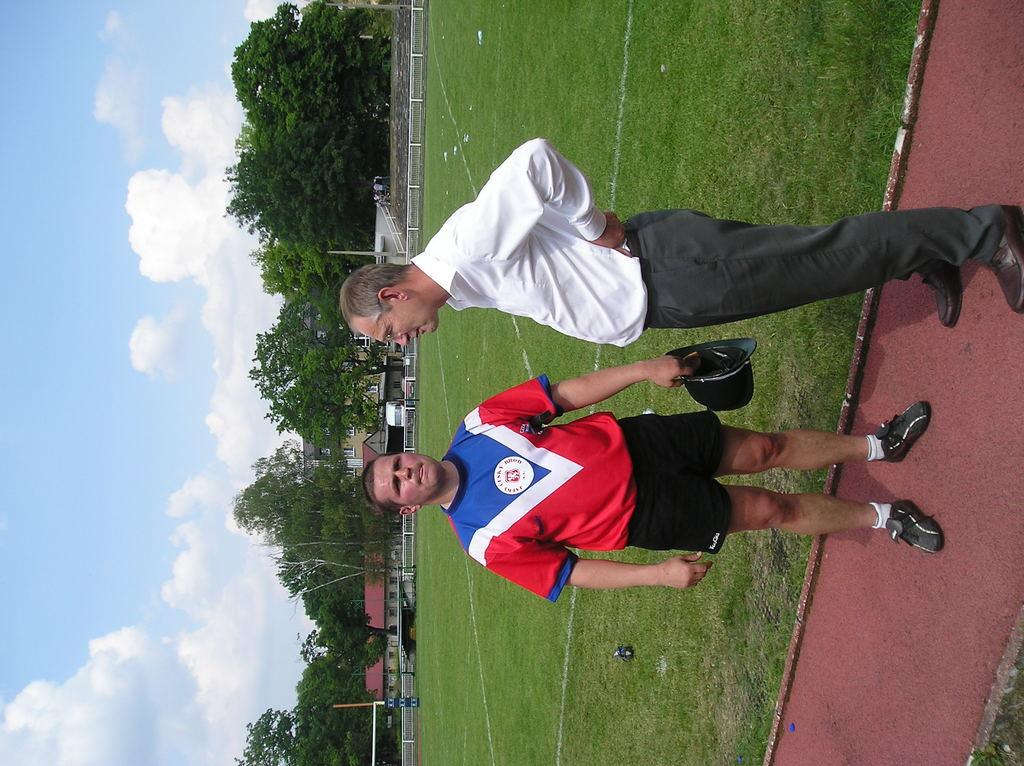What can be seen in the foreground of the image? There are people standing in the foreground of the image. What type of natural environment is visible in the background of the image? There are trees and grassland in the background of the image. What type of structures can be seen in the background of the image? There are houses in the background of the image. What is visible in the sky in the background of the image? The sky is visible in the background of the image. What type of acoustics can be heard from the dinosaurs in the image? There are no dinosaurs present in the image, so there is no acoustics to be heard from them. How does the brake system work on the houses in the image? There is no brake system present in the image, as the image features houses and not vehicles. 